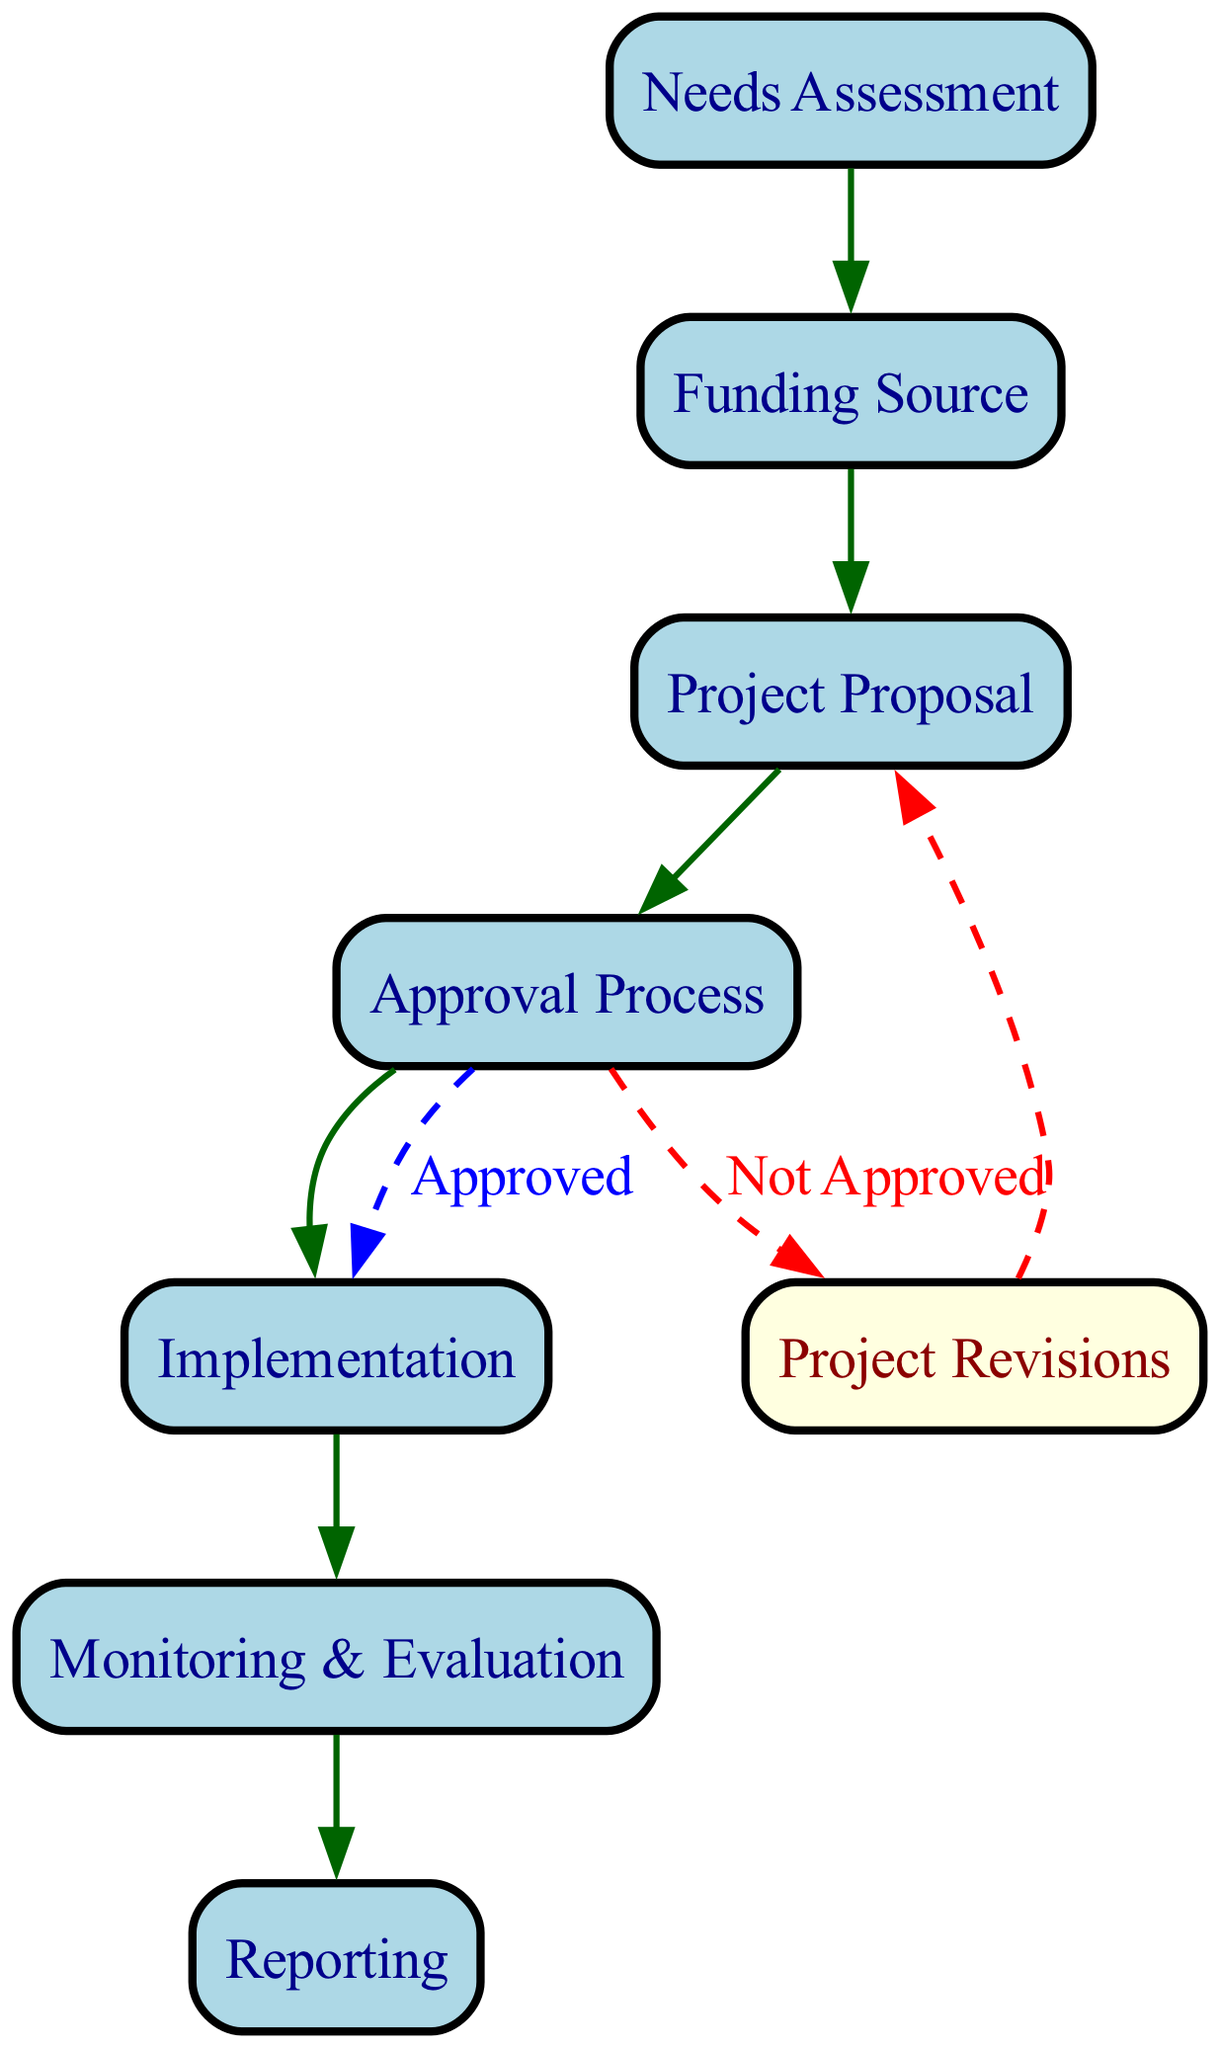What is the first step in the international aid allocation process? The initial node in the directed graph is "Needs Assessment," which indicates that a needs assessment must be conducted first.
Answer: Needs Assessment How many nodes are present in the diagram? By counting the unique nodes listed in the data, there are a total of 7 nodes: Needs Assessment, Funding Source, Project Proposal, Approval Process, Implementation, Monitoring & Evaluation, and Reporting.
Answer: 7 What path follows if the Approval Process is not approved? According to the conditional paths defined, if the Approval Process is not approved, the path leads to "Project Revisions," indicating a need to revise the project proposal.
Answer: Project Revisions What is the condition for proceeding from Approval Process to Implementation? The conditional path specifies that the condition for moving from the Approval Process to Implementation is "Approved," indicating that only when the proposal is approved can implementation commence.
Answer: Approved How many edges connect the nodes in the diagram? The graph contains a total of 6 direct edges connecting the nodes, as listed in the data, each representing the flow from one node to another.
Answer: 6 What happens after Monitoring & Evaluation in the process? The final node is Reporting, which follows the Monitoring & Evaluation step, indicating that after evaluating the process, a report must be created.
Answer: Reporting What is the relationship between Funding Source and Project Proposal? The directed edge from Funding Source to Project Proposal shows that once a funding source is identified, a project proposal is developed based on that funding.
Answer: Project Proposal If a project is approved, what is the next step? Following the approval, the next step in the process is Implementation, indicating that an approved project will move forward to the implementation phase.
Answer: Implementation 